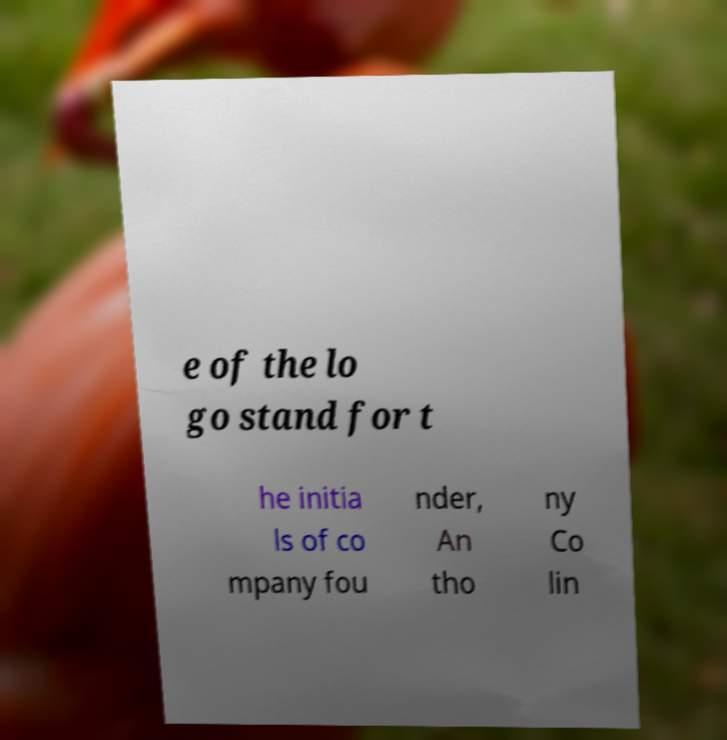Please identify and transcribe the text found in this image. e of the lo go stand for t he initia ls of co mpany fou nder, An tho ny Co lin 